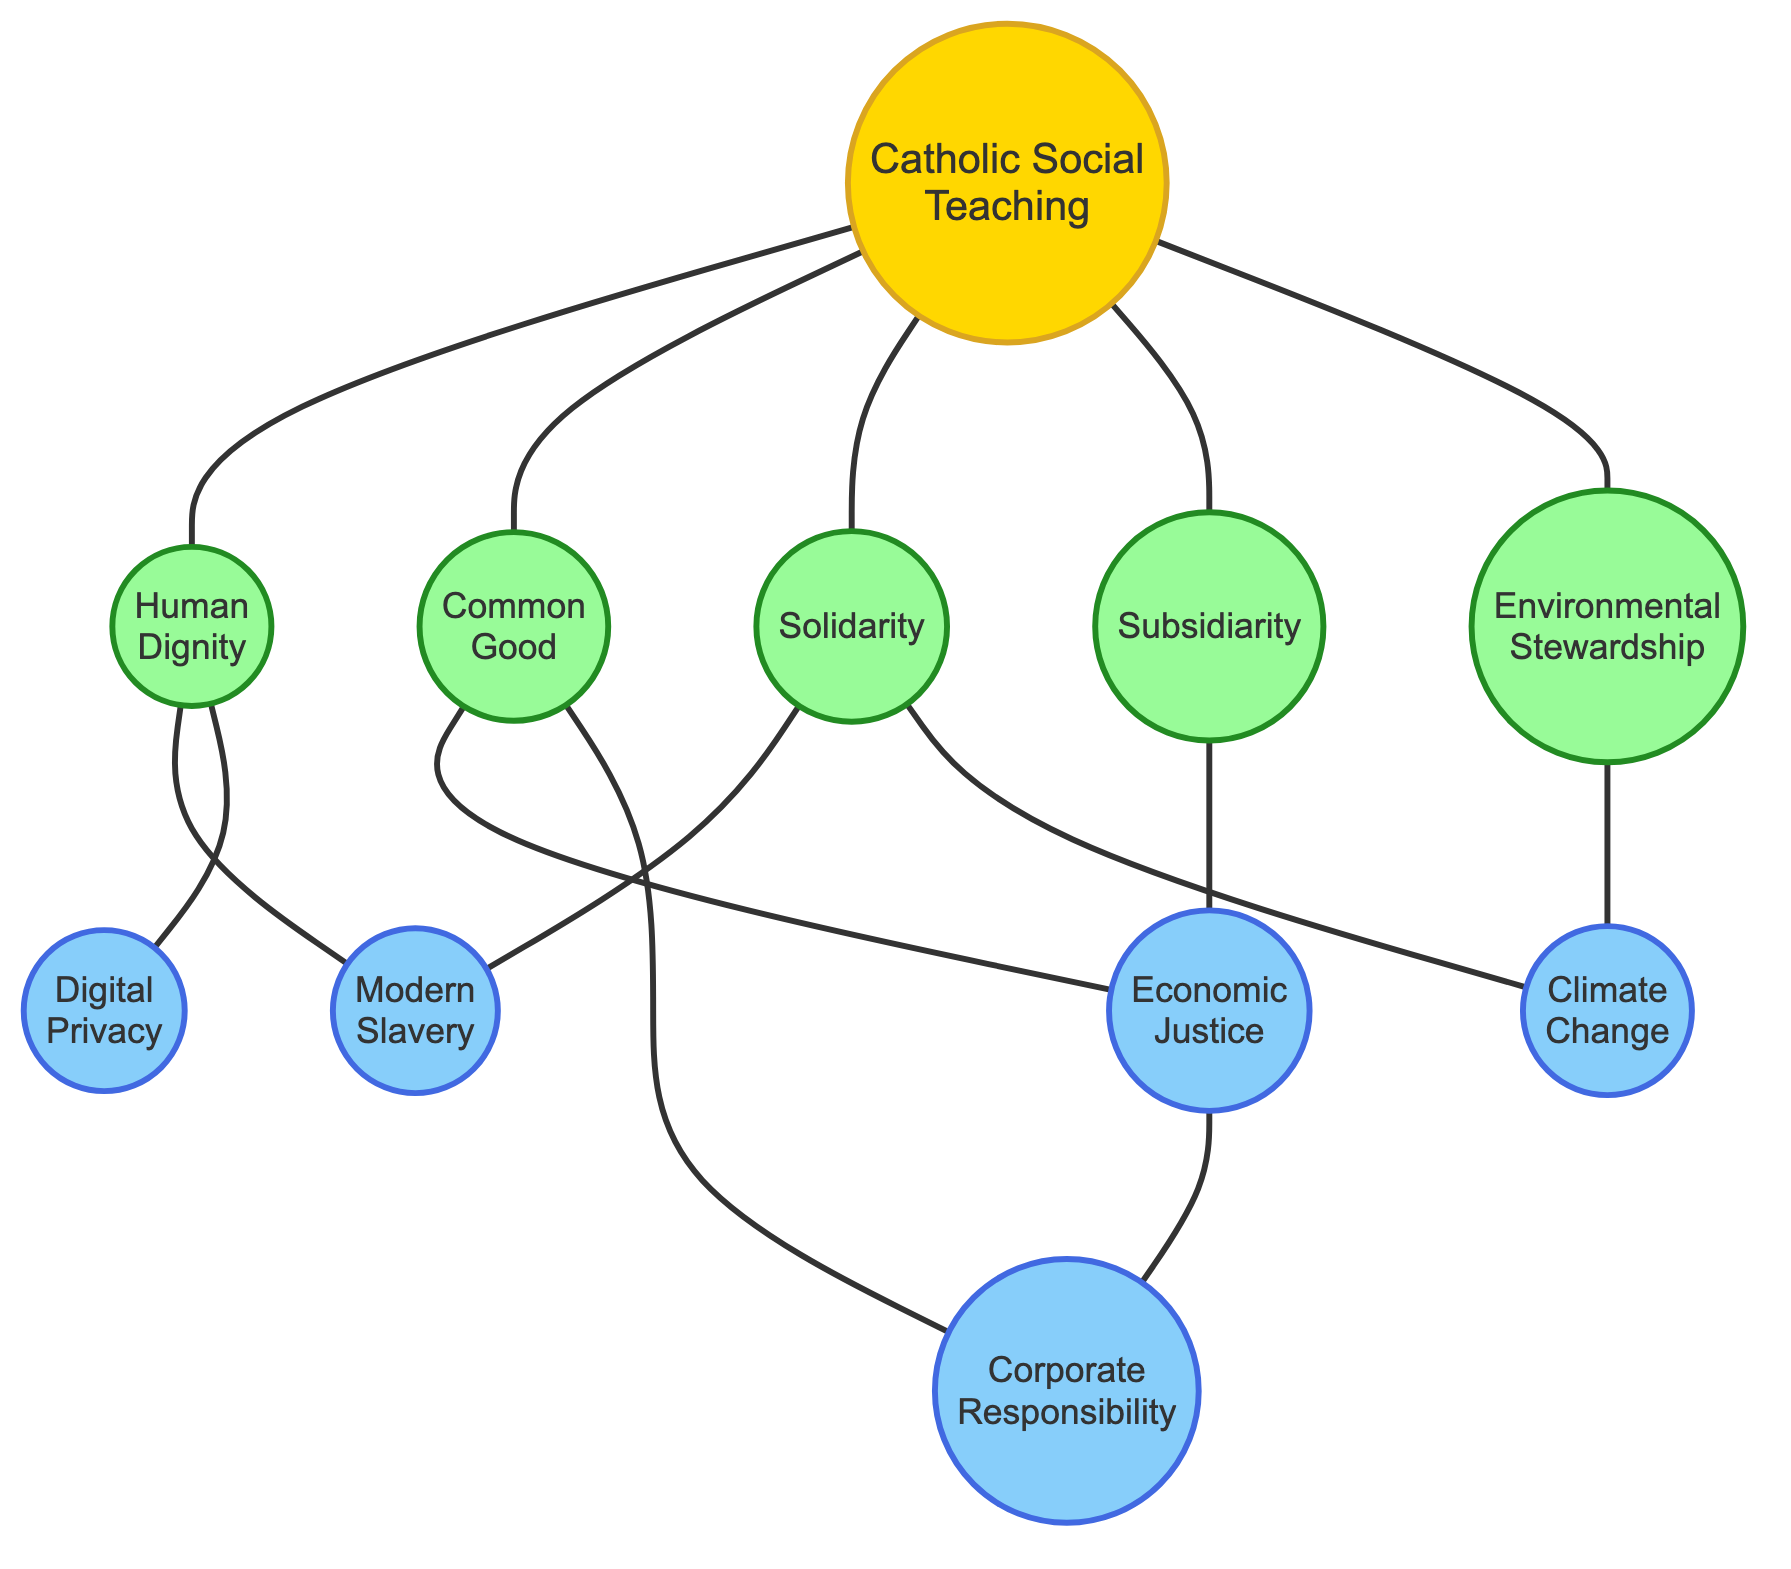What is the total number of nodes in the diagram? The diagram contains a list of nodes that represent key concepts related to Catholic social teachings and modern ethical challenges. Counting each distinct node provides the total number. There are 11 nodes in total.
Answer: 11 Which concepts are directly connected to "Common Good"? To find the concepts directly connected to "Common Good," we look for edges that have "Common Good" as one endpoint. The directly connected nodes are "Economic Justice" and "Corporate Responsibility."
Answer: Economic Justice, Corporate Responsibility How many edges are present in the graph? The number of edges can be determined by counting each line that connects two nodes. Each connection represents a relationship between two concepts. After counting, we find that there are 13 edges in the diagram.
Answer: 13 What are the two nodes directly connected to "Human Dignity"? To find the nodes directly connected to "Human Dignity," we examine the edges associated with it. By reviewing the diagram, the nodes connected are "Modern Slavery" and "Digital Privacy."
Answer: Modern Slavery, Digital Privacy Which concept does "Environmental Stewardship" connect to that also connects to "Climate Change"? To answer this, we find the edges for "Environmental Stewardship" and then see if any of those nodes also have an edge connected to "Climate Change." "Environmental Stewardship" connects to "Climate Change" directly.
Answer: Climate Change How many nodes represent modern ethical challenges in the diagram? Nodes that specifically represent modern ethical challenges can be identified in the diagram under the challenge category. We can count the nodes labeled "Modern Slavery," "Climate Change," "Digital Privacy," "Corporate Responsibility," and "Economic Justice." This gives a total of 5 nodes representing modern ethical challenges.
Answer: 5 Which of the Catholic social teachings is not directly connected to "Economic Justice"? To determine this, we look at all connections from "Economic Justice" and see which Catholic social teachings do not appear. "Human Dignity," "Common Good," "Solidarity," and "Subsidiarity" are connected, while "Environmental Stewardship" is not directly connected.
Answer: Environmental Stewardship Are "Solidarity" and "Modern Slavery" connected? Checking for a direct link between these two nodes involves finding an edge that connects them. In the diagram, there is a direct edge connecting "Solidarity" to "Modern Slavery."
Answer: Yes 